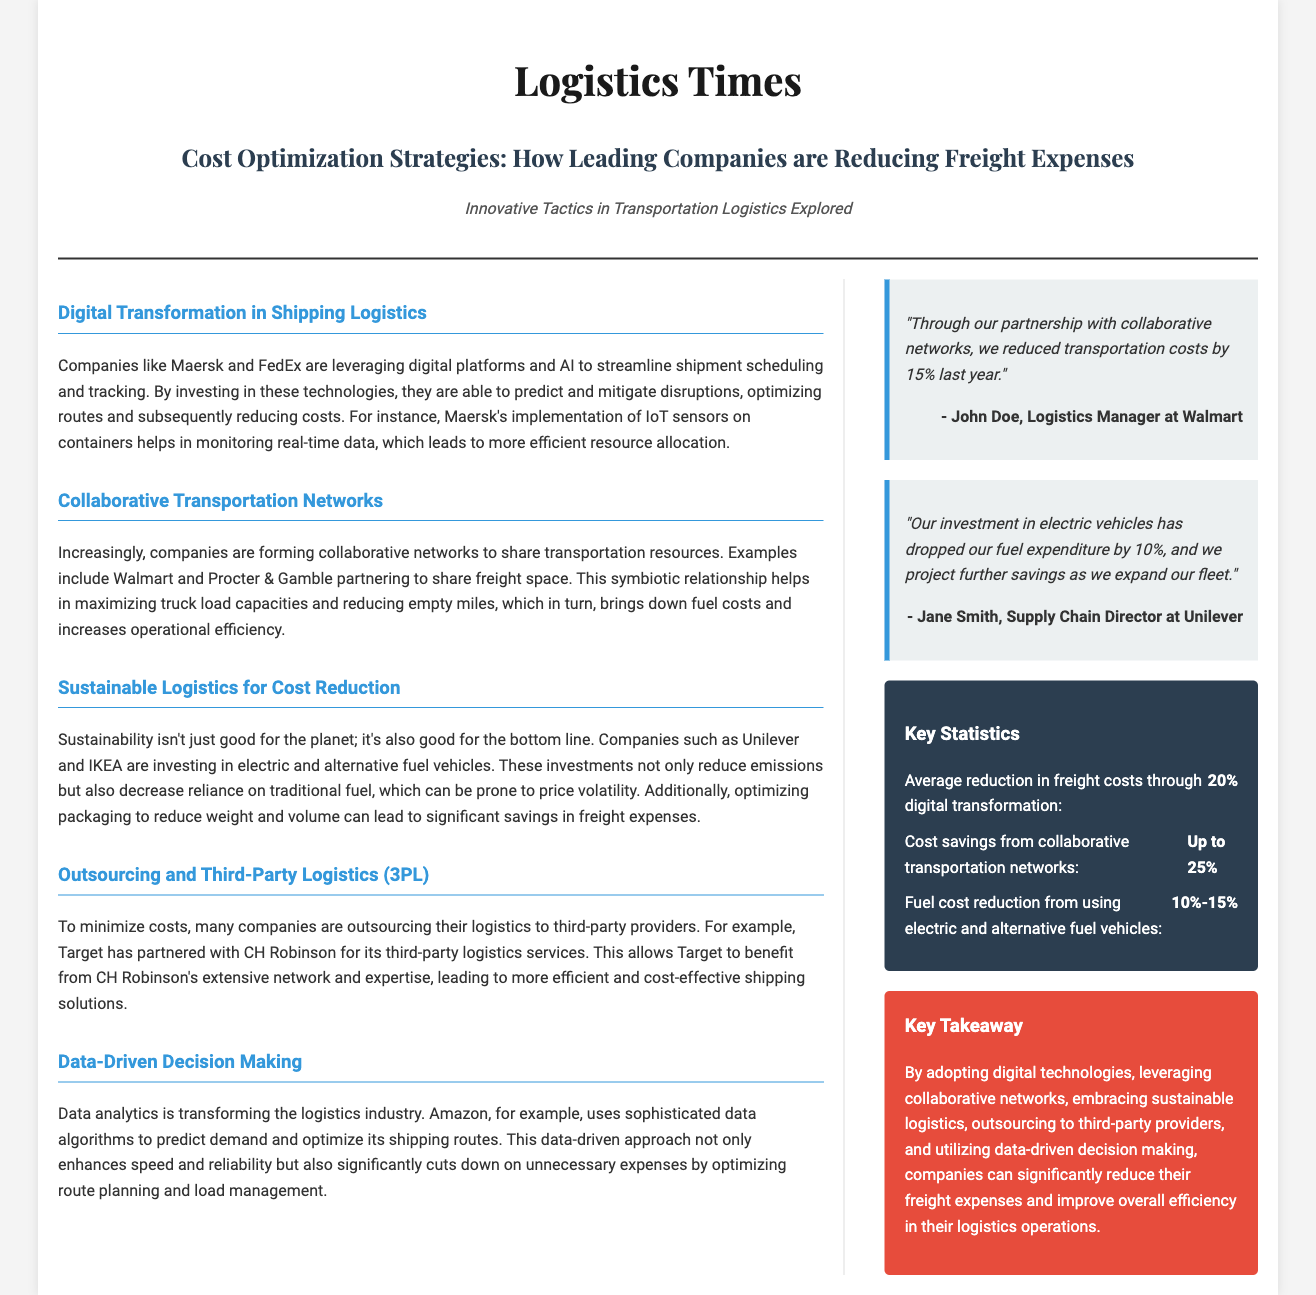What are two companies leveraging digital platforms in shipping logistics? The document mentions Maersk and FedEx as companies leveraging digital platforms to streamline shipment scheduling and tracking.
Answer: Maersk and FedEx What percentage of fuel expenditure has Unilever's investment in electric vehicles reduced? According to the quote from Jane Smith, the investment in electric vehicles has dropped fuel expenditure by 10%.
Answer: 10% What is one key takeaway about freight expense reduction? The callout section summarizes that companies can reduce freight expenses by adopting digital technologies, among other strategies.
Answer: Adopting digital technologies What example of a collaborative transportation network is provided? The document states that Walmart and Procter & Gamble are partnering to share freight space as an example of a collaborative transportation network.
Answer: Walmart and Procter & Gamble What is the expected cost savings from collaborative transportation networks? The document mentions that cost savings from collaborative transportation networks can be as high as 25%.
Answer: Up to 25% What technology does Maersk implement to monitor real-time data? The document states that Maersk implements IoT sensors on containers to monitor real-time data.
Answer: IoT sensors How much can freight costs be reduced through digital transformation? According to the key statistics, the average reduction in freight costs through digital transformation is 20%.
Answer: 20% What is the main focus of the article? The title and subheadline indicate that the primary focus is on cost optimization strategies in reducing freight expenses.
Answer: Cost optimization strategies 